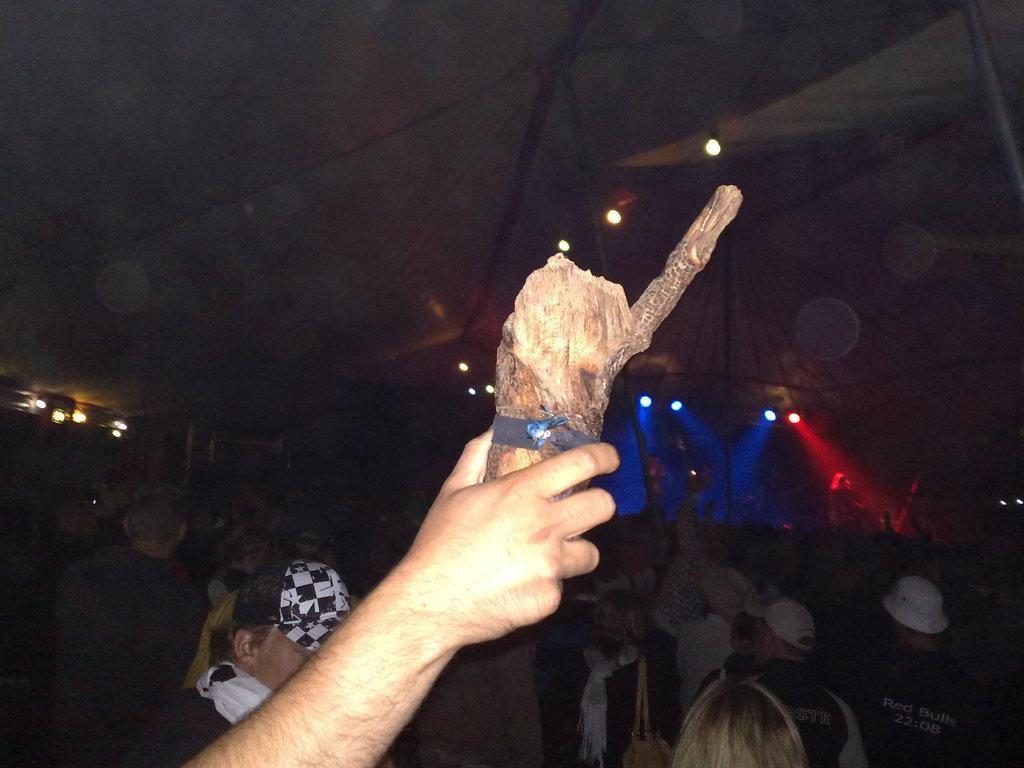Could you give a brief overview of what you see in this image? In this picture we can observe a human hand holding a wooden piece. There are some people in this picture. In the background we can observe blue and red color lights. The background is dark. 